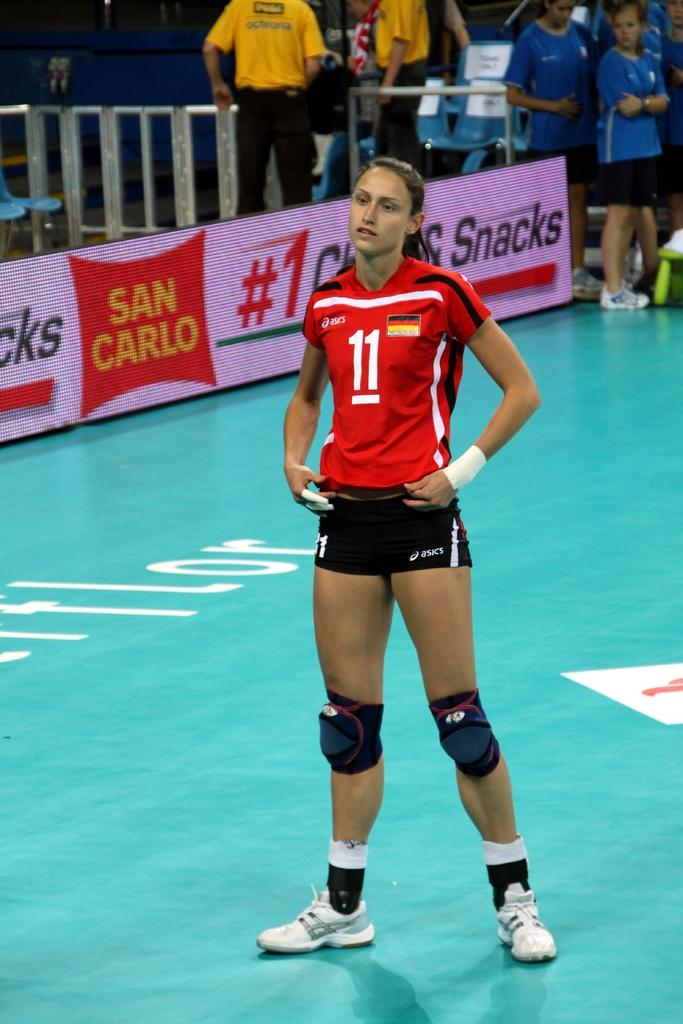<image>
Present a compact description of the photo's key features. The sports player girl has #11 on her top with SAN CARLO brand snacks advertised on the banner on the side. 